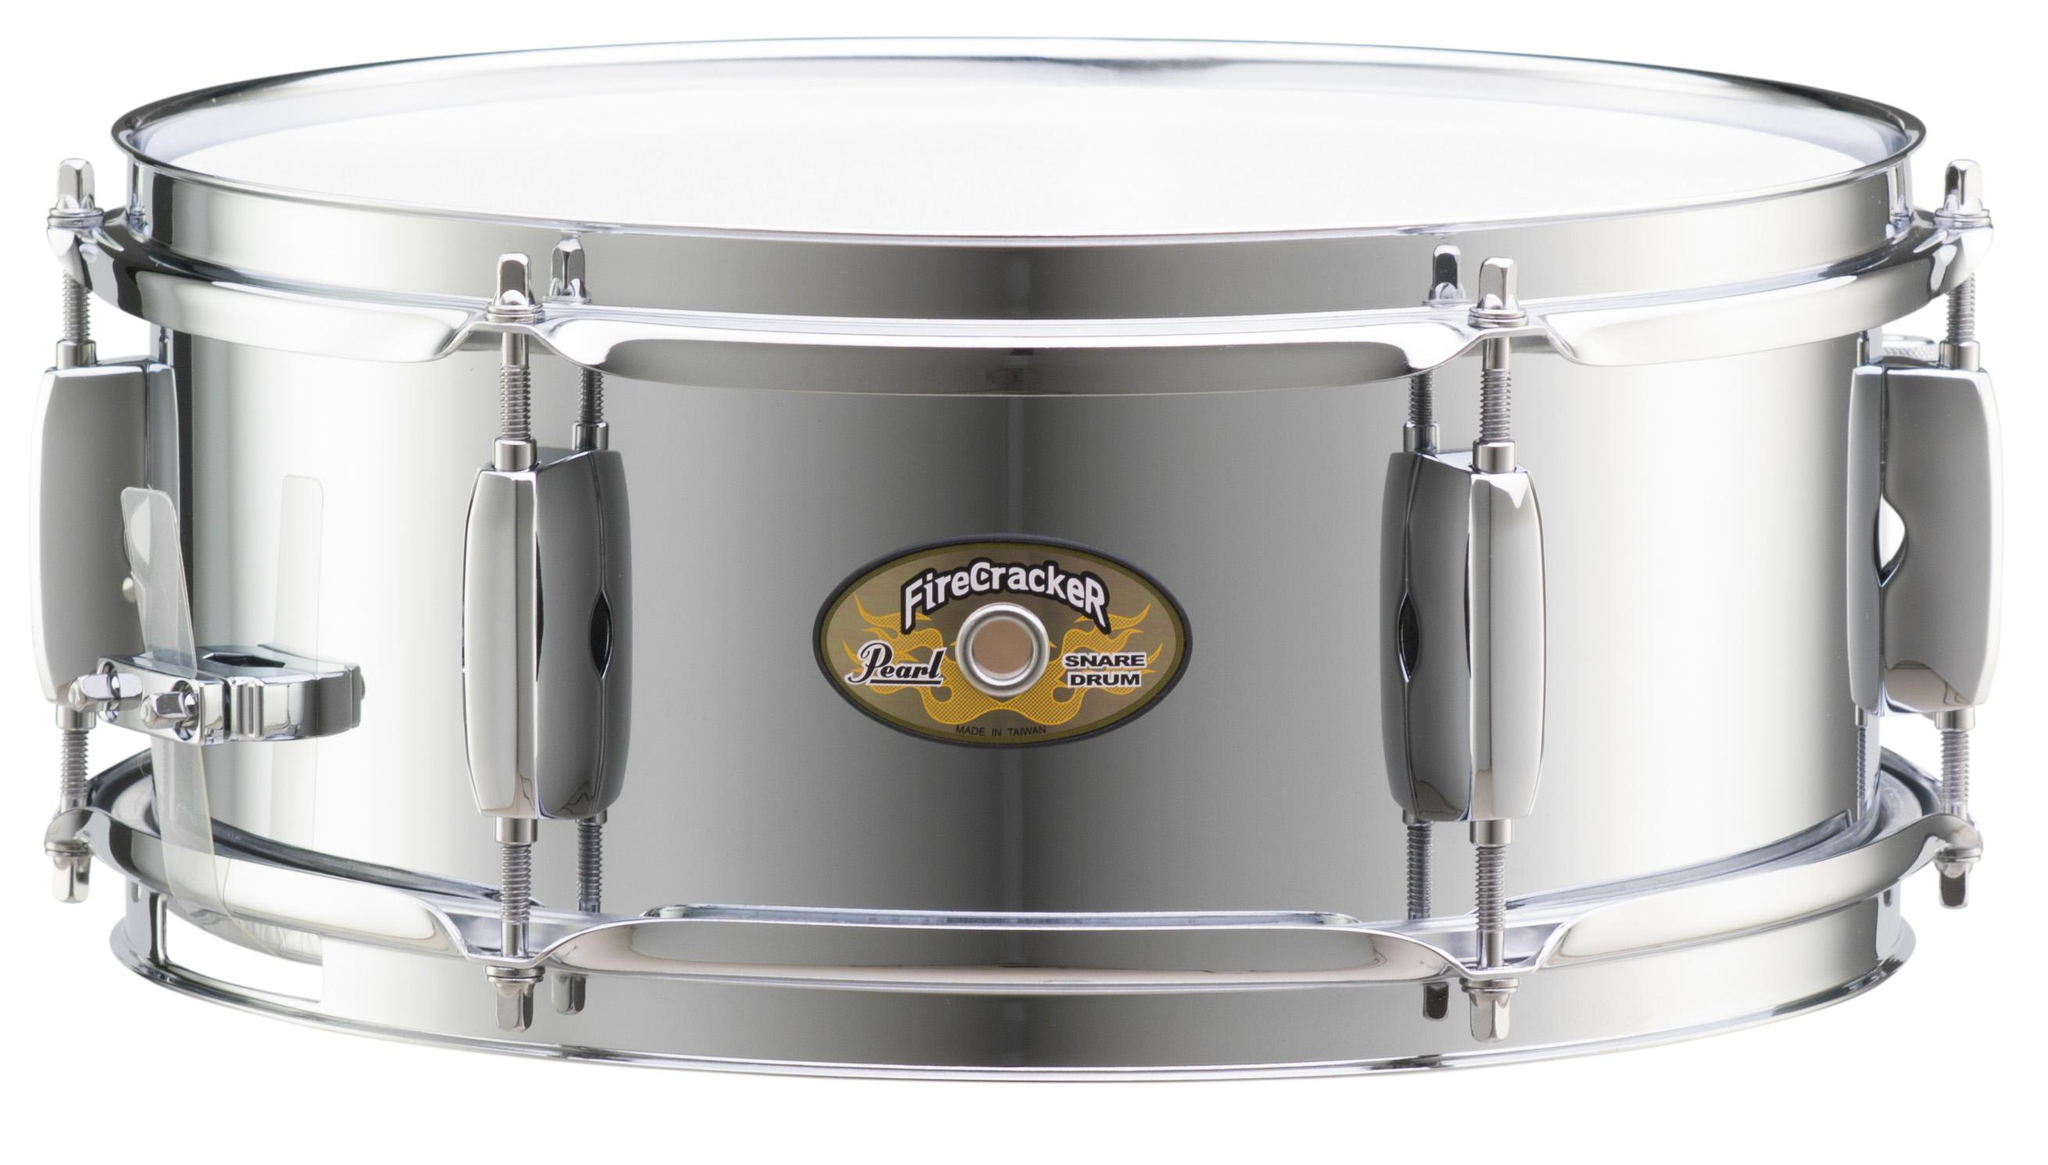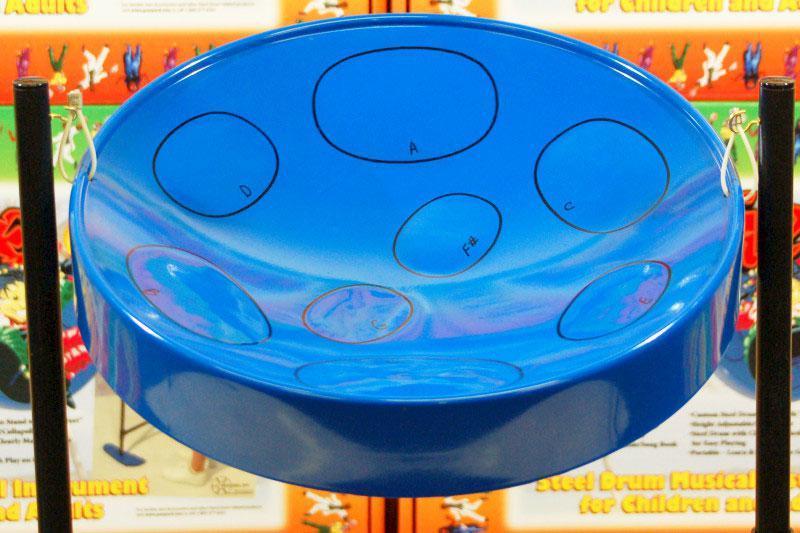The first image is the image on the left, the second image is the image on the right. Analyze the images presented: Is the assertion "The right image features one drum with a concave top on a pivoting black stand, and the left image includes at least one cylindrical flat-topped drum displayed sitting on a flat side." valid? Answer yes or no. Yes. The first image is the image on the left, the second image is the image on the right. Examine the images to the left and right. Is the description "There are drums stacked on top of one another." accurate? Answer yes or no. No. 